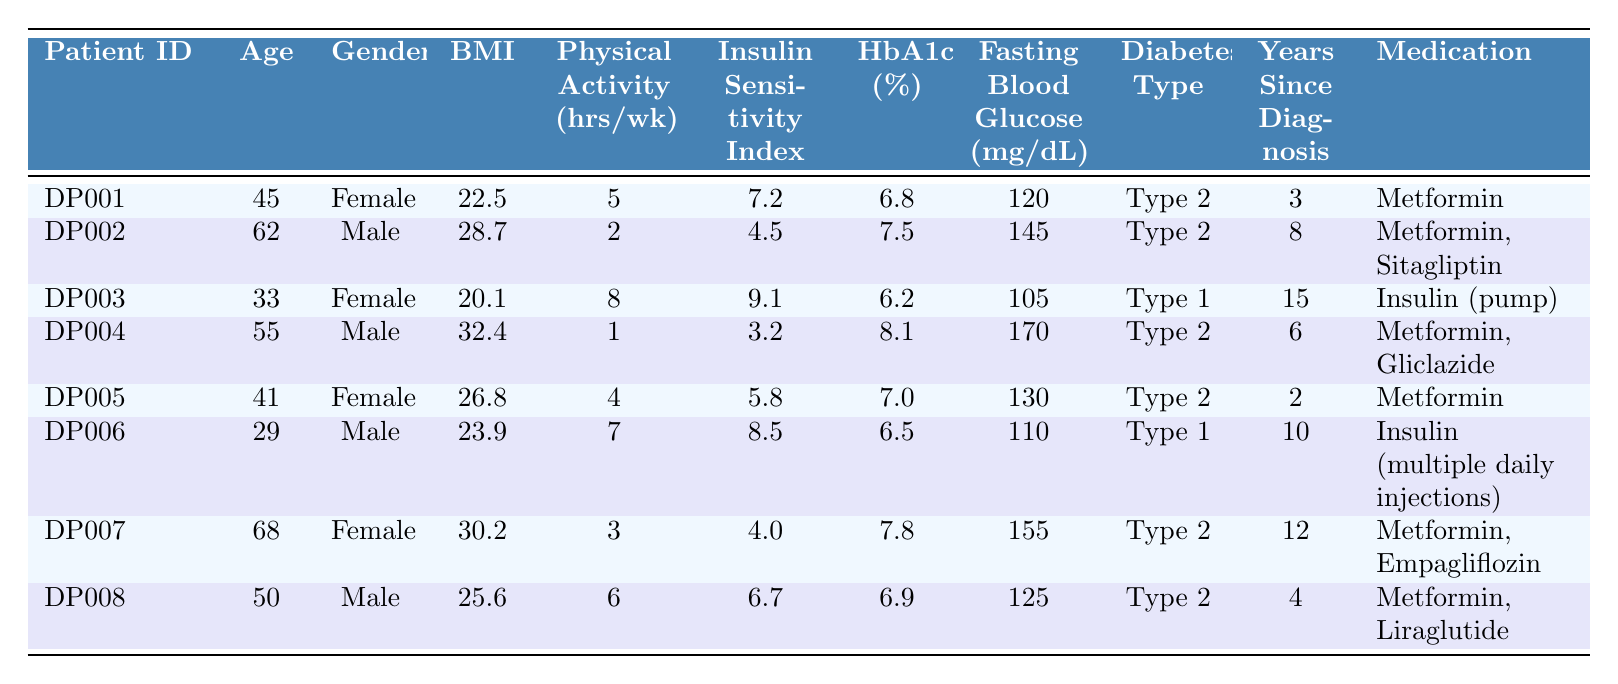What is the physical activity level of Patient ID DP003? The physical activity level is listed in the table under the header "Physical Activity Level (hours/week)". For Patient ID DP003, this value is 8 hours/week.
Answer: 8 hours/week Which patient has the highest Insulin Sensitivity Index? The Insulin Sensitivity Index values are provided for each patient in the "Insulin Sensitivity Index" column. DP003 has the highest value of 9.1.
Answer: DP003 What is the average BMI of all patients in the table? To find the average BMI, we first sum the BMIs: (22.5 + 28.7 + 20.1 + 32.4 + 26.8 + 23.9 + 30.2 + 25.6) = 209.2. Then, we divide by the number of patients (8): 209.2 / 8 = 26.15.
Answer: 26.15 Is there a patient with both Type 1 diabetes and a physical activity level greater than 6 hours/week? Looking at the table, DP003 has Type 1 diabetes and a physical activity level of 8 hours/week. Therefore, the answer is yes.
Answer: Yes What is the difference in HbA1c percentage between the patient with the highest and the lowest HbA1c%? The highest HbA1c% is 8.1 (DP004) and the lowest is 6.2 (DP003). The difference is 8.1 - 6.2 = 1.9.
Answer: 1.9 How many patients have a physical activity level of less than 3 hours/week? Reviewing the physical activity levels, DP002 (2 hours/week) and DP004 (1 hour/week) have levels less than 3. This gives us a total of 2 patients.
Answer: 2 patients What is the relationship between BMI and Insulin Sensitivity Index for patients with Type 2 diabetes? For Type 2 diabetes patients (DP002, DP004, DP005, DP007, DP008), their BMIs are 28.7, 32.4, 26.8, 30.2, and 25.6, and their Insulin Sensitivity Indexes are 4.5, 3.2, 5.8, 4.0, and 6.7, respectively. As BMI increases, the ISI tends to decrease, suggesting a negative correlation.
Answer: Negative correlation What is the average years since diagnosis for patients with a BMI over 30? For patients with BMI over 30, they are DP002 (8 years), DP004 (6 years), and DP007 (12 years). Summing these gives 8 + 6 + 12 = 26. Dividing by 3 gives us 26 / 3 = 8.67 years.
Answer: 8.67 years Do all patients with a higher Insulin Sensitivity Index have lower HbA1c levels? Checking the table, patient DP003 (Insulin Sensitivity Index 9.1) has HbA1c% of 6.2, and patient DP001 (ISI 7.2) has 6.8. However, DP007 (ISI 4.0) has 7.8, which is higher than both DP001 and DP003. Thus, the answer is no because not all patients with higher ISI have lower HbA1c.
Answer: No 